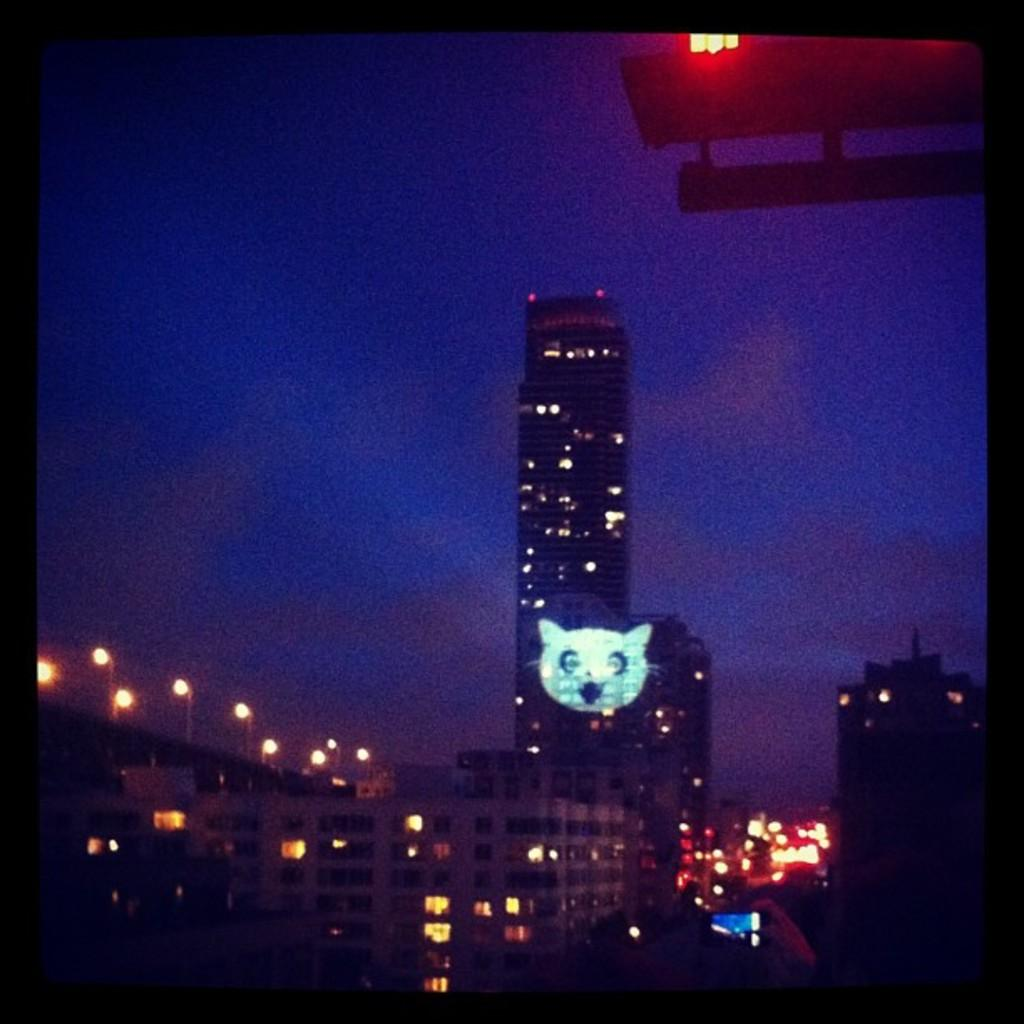What type of structures are visible in the image? There are many buildings with lights in the image. What can be seen on top of the poles in the image? There are poles with street lights in the image. How would you describe the overall lighting in the image? The background of the image is dark, but the buildings and street lights provide illumination. Can you see the ocean in the image? No, there is no ocean visible in the image. What type of soap is being used to clean the buildings in the image? There is no soap or cleaning activity depicted in the image. 